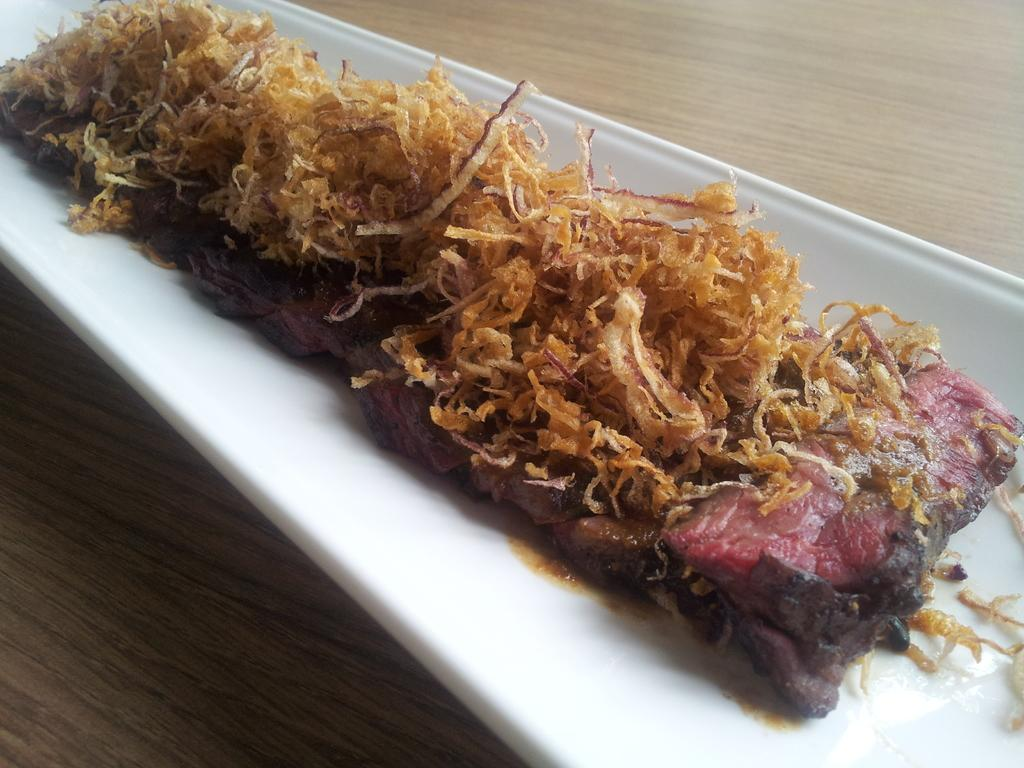What is the color of the plate that is visible in the image? There is a white plate in the image. Where is the white plate located? The white plate is on a wooden surface. What is on top of the white plate? There is a food item on the white plate. What type of watch is visible on the wooden surface in the image? There is no watch present in the image; it only features a white plate on a wooden surface with a food item on it. 